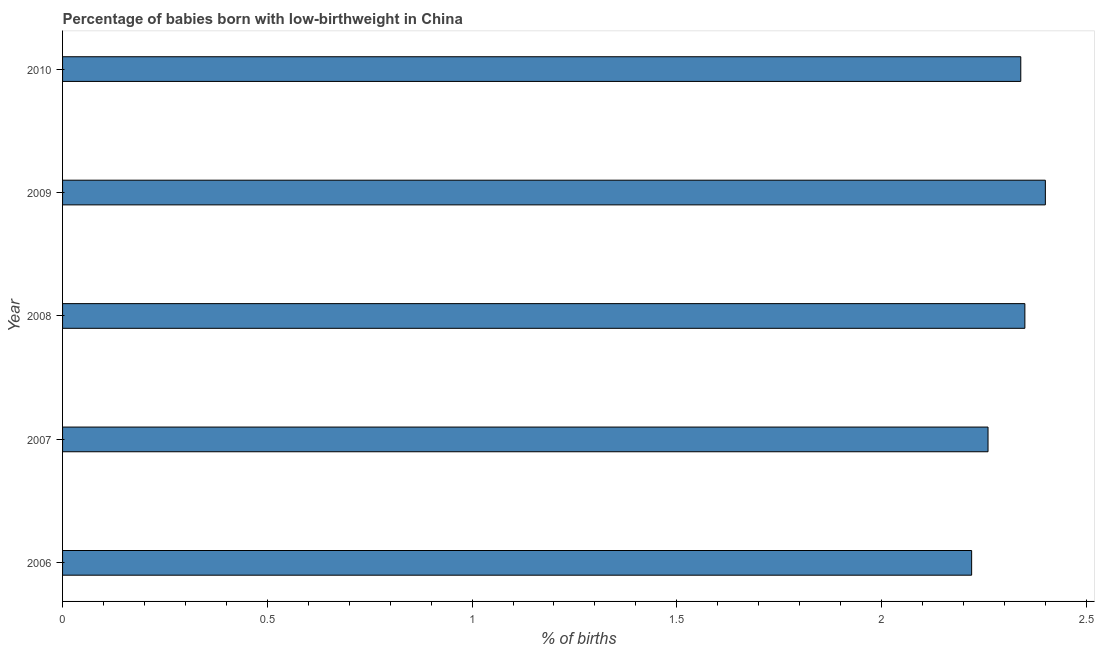What is the title of the graph?
Offer a terse response. Percentage of babies born with low-birthweight in China. What is the label or title of the X-axis?
Make the answer very short. % of births. What is the label or title of the Y-axis?
Your answer should be very brief. Year. What is the percentage of babies who were born with low-birthweight in 2008?
Keep it short and to the point. 2.35. Across all years, what is the minimum percentage of babies who were born with low-birthweight?
Offer a terse response. 2.22. What is the sum of the percentage of babies who were born with low-birthweight?
Your answer should be compact. 11.57. What is the difference between the percentage of babies who were born with low-birthweight in 2007 and 2008?
Offer a terse response. -0.09. What is the average percentage of babies who were born with low-birthweight per year?
Offer a very short reply. 2.31. What is the median percentage of babies who were born with low-birthweight?
Provide a short and direct response. 2.34. In how many years, is the percentage of babies who were born with low-birthweight greater than 0.4 %?
Provide a succinct answer. 5. Do a majority of the years between 2008 and 2007 (inclusive) have percentage of babies who were born with low-birthweight greater than 1.8 %?
Your answer should be compact. No. Is the percentage of babies who were born with low-birthweight in 2007 less than that in 2009?
Offer a terse response. Yes. Is the difference between the percentage of babies who were born with low-birthweight in 2009 and 2010 greater than the difference between any two years?
Offer a terse response. No. Is the sum of the percentage of babies who were born with low-birthweight in 2007 and 2009 greater than the maximum percentage of babies who were born with low-birthweight across all years?
Provide a short and direct response. Yes. What is the difference between the highest and the lowest percentage of babies who were born with low-birthweight?
Provide a short and direct response. 0.18. What is the % of births of 2006?
Your answer should be very brief. 2.22. What is the % of births of 2007?
Ensure brevity in your answer.  2.26. What is the % of births of 2008?
Provide a succinct answer. 2.35. What is the % of births in 2010?
Provide a short and direct response. 2.34. What is the difference between the % of births in 2006 and 2007?
Your response must be concise. -0.04. What is the difference between the % of births in 2006 and 2008?
Offer a very short reply. -0.13. What is the difference between the % of births in 2006 and 2009?
Make the answer very short. -0.18. What is the difference between the % of births in 2006 and 2010?
Provide a succinct answer. -0.12. What is the difference between the % of births in 2007 and 2008?
Your response must be concise. -0.09. What is the difference between the % of births in 2007 and 2009?
Keep it short and to the point. -0.14. What is the difference between the % of births in 2007 and 2010?
Offer a terse response. -0.08. What is the difference between the % of births in 2008 and 2009?
Make the answer very short. -0.05. What is the difference between the % of births in 2008 and 2010?
Provide a short and direct response. 0.01. What is the ratio of the % of births in 2006 to that in 2007?
Keep it short and to the point. 0.98. What is the ratio of the % of births in 2006 to that in 2008?
Offer a terse response. 0.94. What is the ratio of the % of births in 2006 to that in 2009?
Your answer should be compact. 0.93. What is the ratio of the % of births in 2006 to that in 2010?
Keep it short and to the point. 0.95. What is the ratio of the % of births in 2007 to that in 2009?
Keep it short and to the point. 0.94. What is the ratio of the % of births in 2007 to that in 2010?
Your answer should be very brief. 0.97. What is the ratio of the % of births in 2008 to that in 2010?
Your response must be concise. 1. 